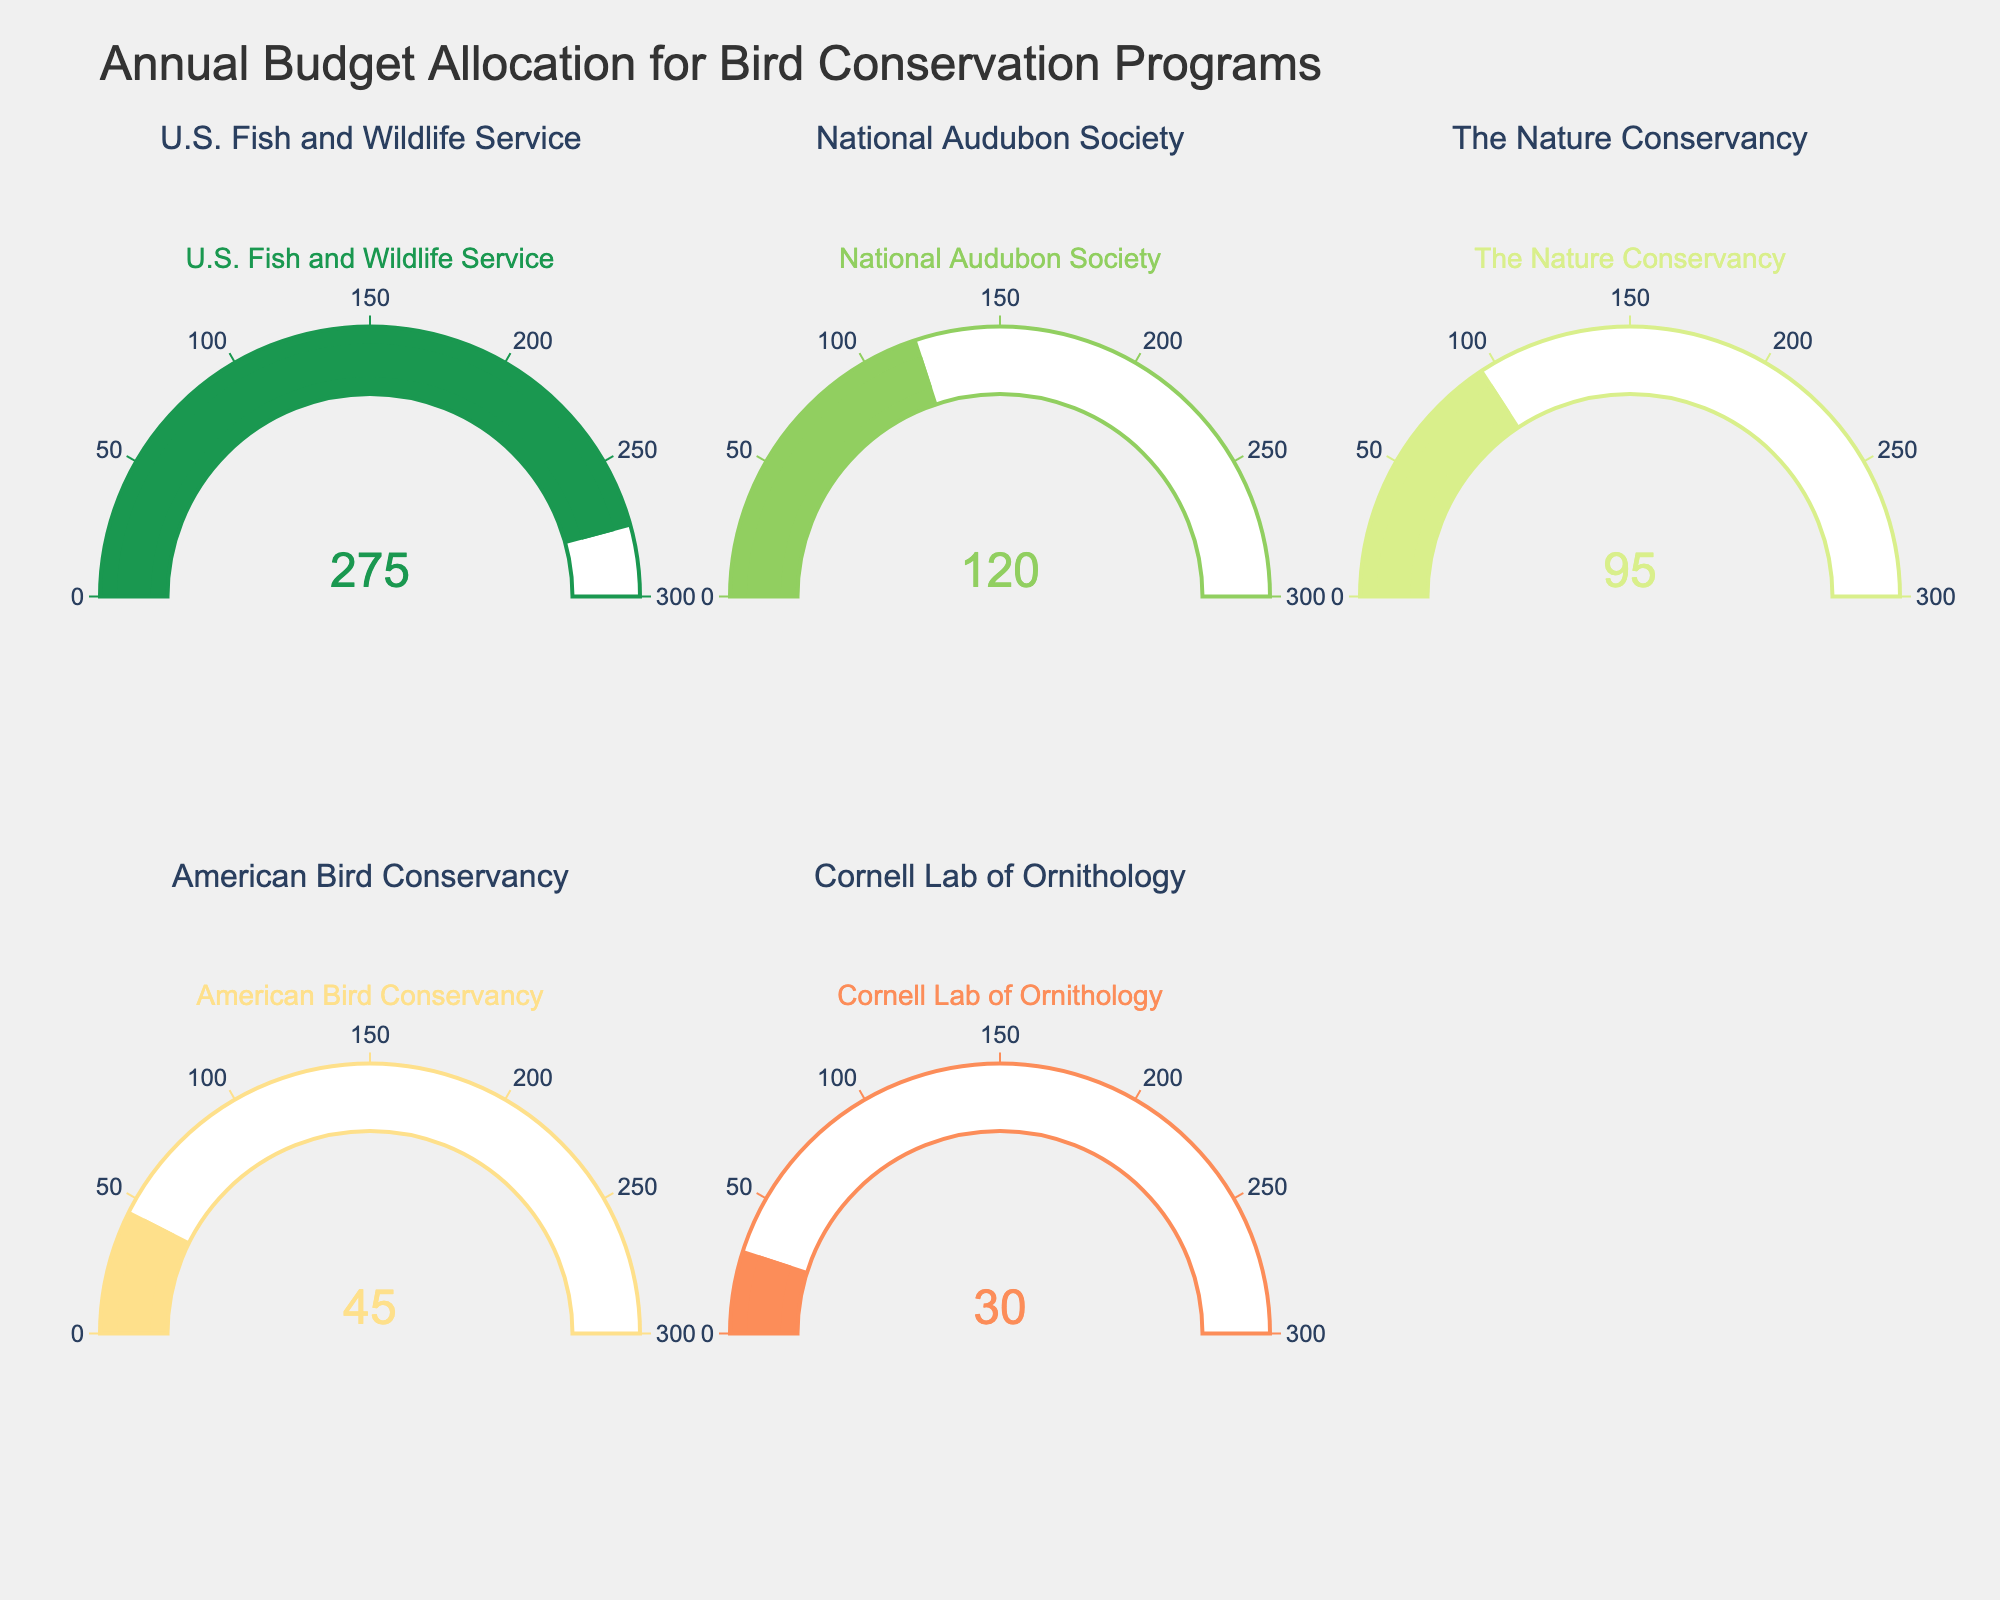what is the title of the figure? The title is positioned at the top center of the figure in a larger, bold font that reads "Annual Budget Allocation for Bird Conservation Programs".
Answer: Annual Budget Allocation for Bird Conservation Programs what's the budget allocation of the National Audubon Society? The gauge for the National Audubon Society shows the number 120, indicating its budget allocation in million USD.
Answer: 120 compare the budget allocations of the U.S. Fish and Wildlife Service and the American Bird Conservancy. Which organization has a larger budget, and by how much? The U.S. Fish and Wildlife Service has 275 million USD, and the American Bird Conservancy has 45 million USD. The difference is 275 - 45 = 230 million USD.
Answer: U.S. Fish and Wildlife Service by 230 million USD how many organizations have a budget allocation above 100 million USD? The budgets above 100 million USD are shown for the U.S. Fish and Wildlife Service (275) and the National Audubon Society (120). Thus, there are 2 organizations.
Answer: 2 which organization has the smallest budget allocation and what is that amount? The organization with the smallest budget allocation is the Cornell Lab of Ornithology, with 30 million USD, as evidenced by the lowest value displayed amongst the gauges.
Answer: Cornell Lab of Ornithology, 30 million USD what is the total budget allocation for all organizations combined? Summing the values of all the gauges: 275 + 120 + 95 + 45 + 30 = 565 million USD.
Answer: 565 million USD is the budget of The Nature Conservancy closer to that of National Audubon Society or American Bird Conservancy? The Nature Conservancy has a budget of 95 million USD. The difference from National Audubon Society (120) is 120 - 95 = 25. The difference from American Bird Conservancy (45) is 95 - 45 = 50. Since 25 is less than 50, it is closer to National Audubon Society's budget.
Answer: National Audubon Society what is the average budget allocation for the listed organizations? The total budget allocation is 565 million USD, and there are 5 organizations. Average = 565 / 5 = 113 million USD.
Answer: 113 million USD 